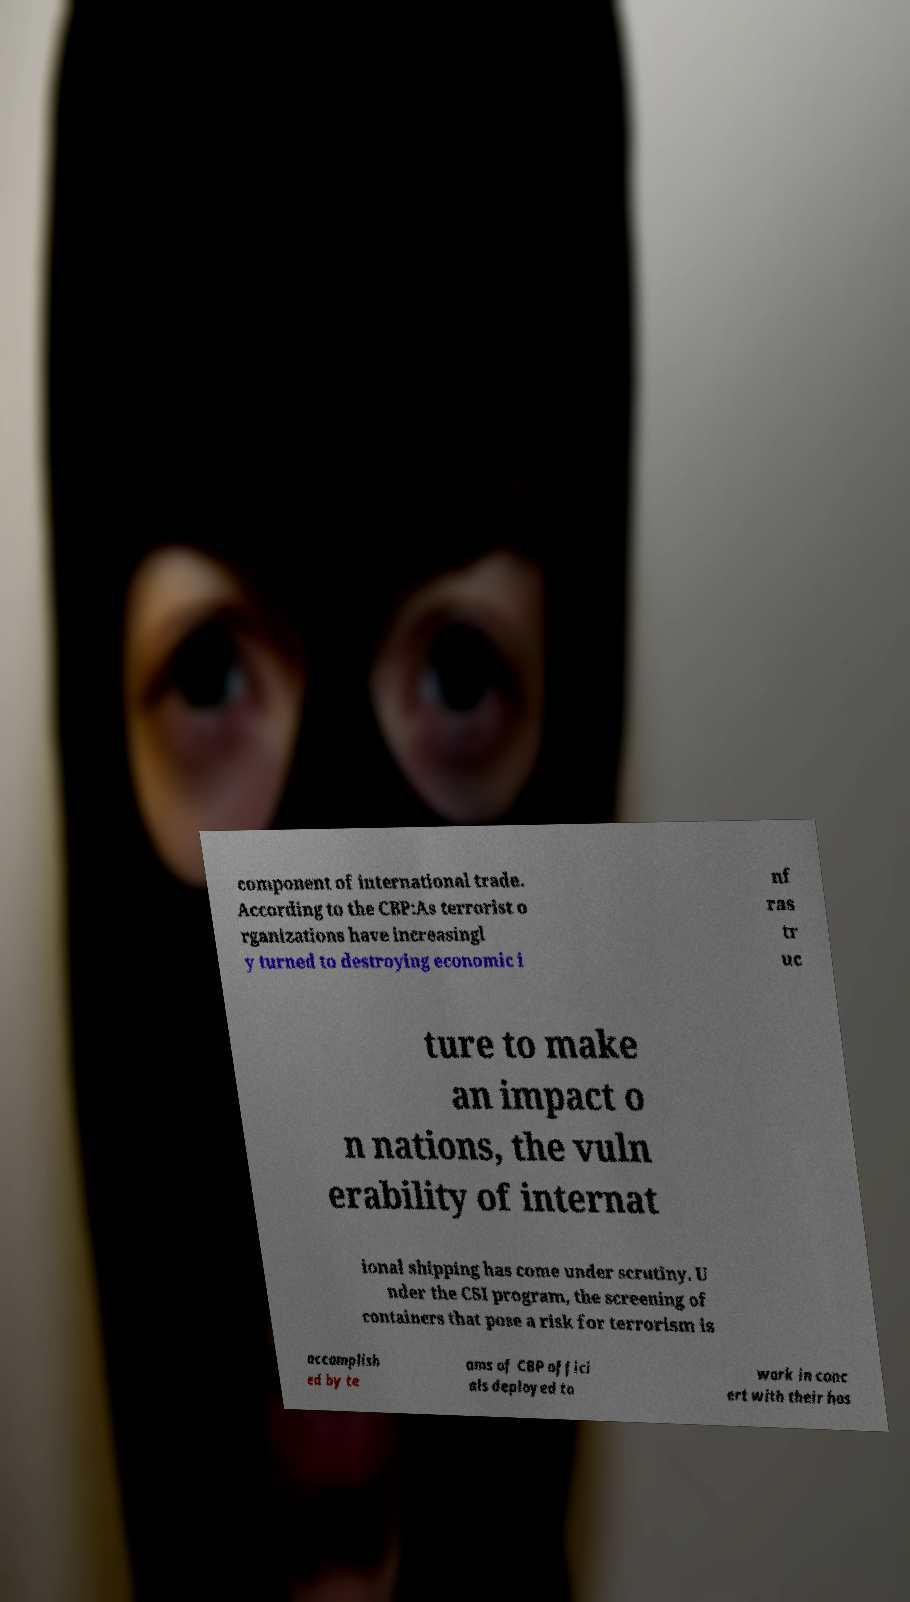Can you read and provide the text displayed in the image?This photo seems to have some interesting text. Can you extract and type it out for me? component of international trade. According to the CBP:As terrorist o rganizations have increasingl y turned to destroying economic i nf ras tr uc ture to make an impact o n nations, the vuln erability of internat ional shipping has come under scrutiny. U nder the CSI program, the screening of containers that pose a risk for terrorism is accomplish ed by te ams of CBP offici als deployed to work in conc ert with their hos 